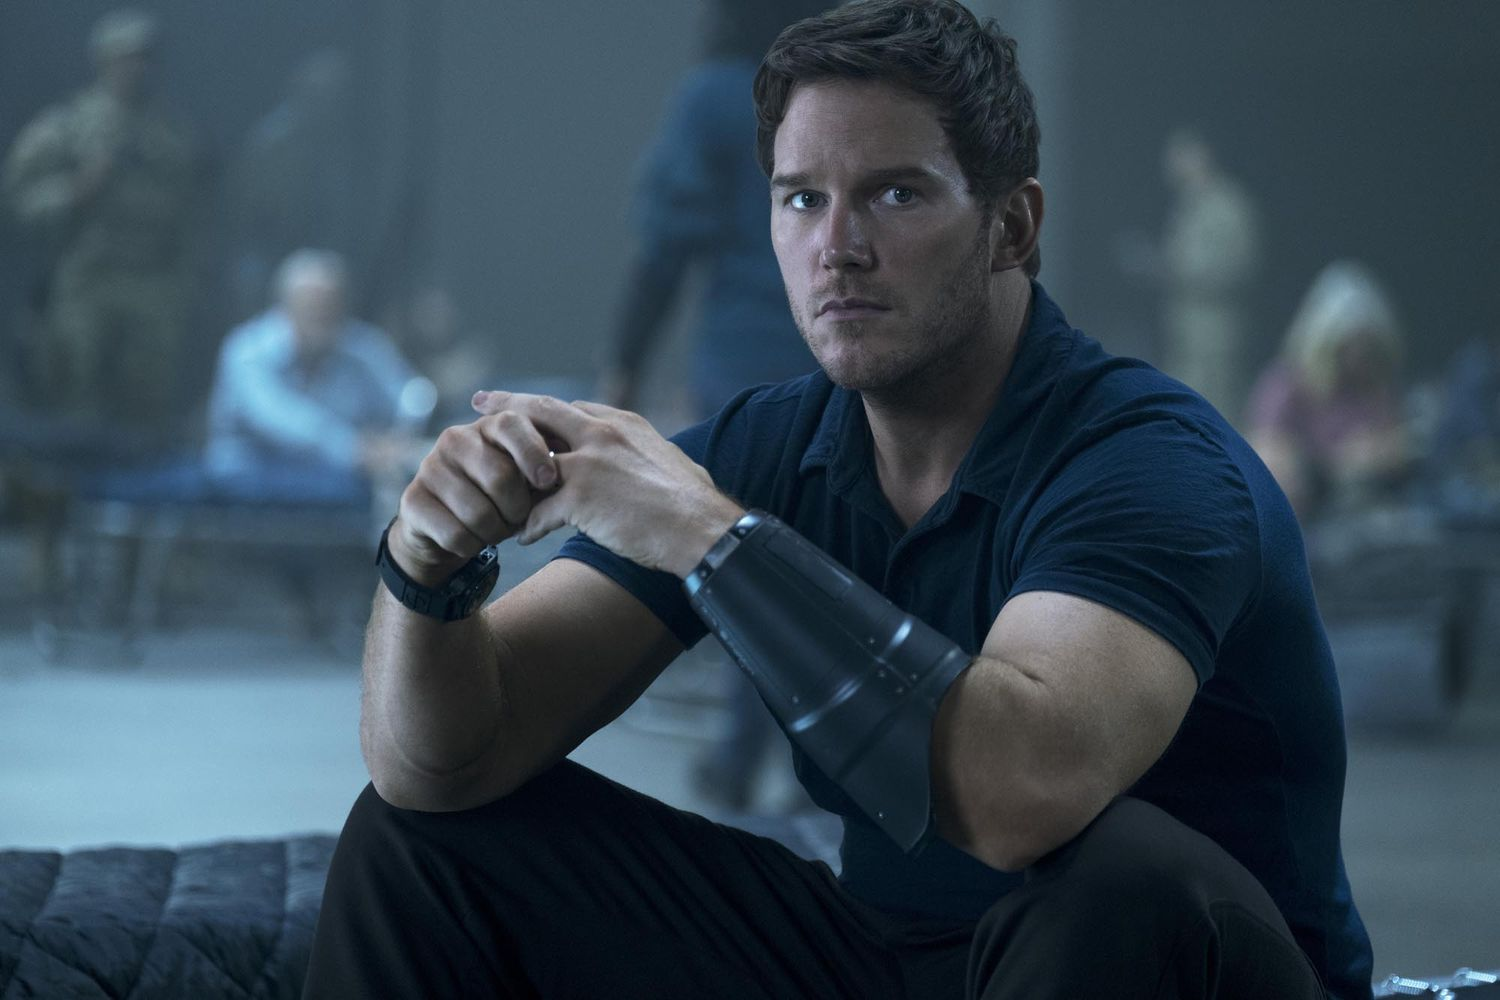What are the key elements in this picture? The image features a character, presumably a central figure, seated on a black bench. He is wearing a dark blue shirt and an armored wrist guard, giving him a rugged and prepared look. His expression is serious, underpinning the tension of the situation. In his hands, he is holding a black device, suggesting it might be significant to the scenario. The background, though blurred, shows several people and soldiers, implying a busy, high-stakes, or possibly wartime setting. The focus is clearly on this character and his actions, highlighting his importance in the scene. 